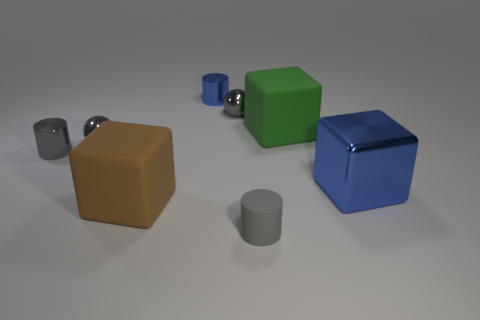Is the number of tiny cylinders on the right side of the large brown rubber thing greater than the number of metallic blocks left of the small blue shiny cylinder?
Provide a succinct answer. Yes. What is the size of the rubber cylinder?
Provide a succinct answer. Small. Are there any big green things that have the same shape as the brown object?
Provide a succinct answer. Yes. Does the large brown rubber object have the same shape as the rubber thing behind the large brown matte cube?
Your answer should be compact. Yes. There is a object that is both left of the small rubber cylinder and in front of the big blue metal cube; what is its size?
Offer a terse response. Large. What number of metal cylinders are there?
Ensure brevity in your answer.  2. What is the material of the blue block that is the same size as the green thing?
Your response must be concise. Metal. Is there a gray object of the same size as the gray metallic cylinder?
Ensure brevity in your answer.  Yes. Do the tiny metal cylinder that is on the right side of the gray metallic cylinder and the metal thing in front of the gray shiny cylinder have the same color?
Offer a very short reply. Yes. How many rubber objects are large spheres or brown things?
Ensure brevity in your answer.  1. 